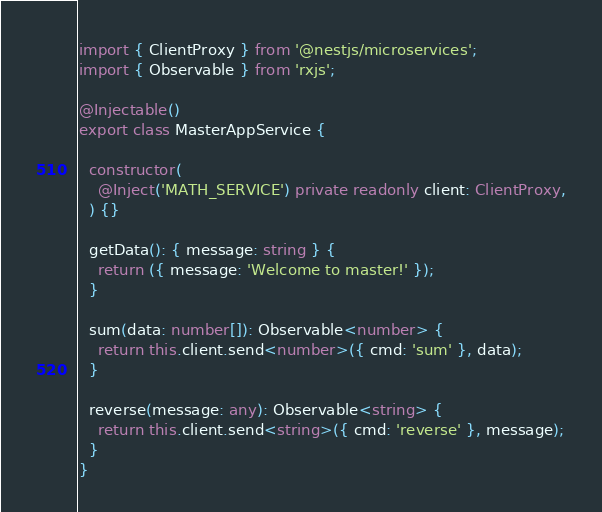<code> <loc_0><loc_0><loc_500><loc_500><_TypeScript_>import { ClientProxy } from '@nestjs/microservices';
import { Observable } from 'rxjs';

@Injectable()
export class MasterAppService {

  constructor(
    @Inject('MATH_SERVICE') private readonly client: ClientProxy,
  ) {}

  getData(): { message: string } {
    return ({ message: 'Welcome to master!' });
  }

  sum(data: number[]): Observable<number> {
    return this.client.send<number>({ cmd: 'sum' }, data);
  }

  reverse(message: any): Observable<string> {
    return this.client.send<string>({ cmd: 'reverse' }, message);
  }
}
</code> 